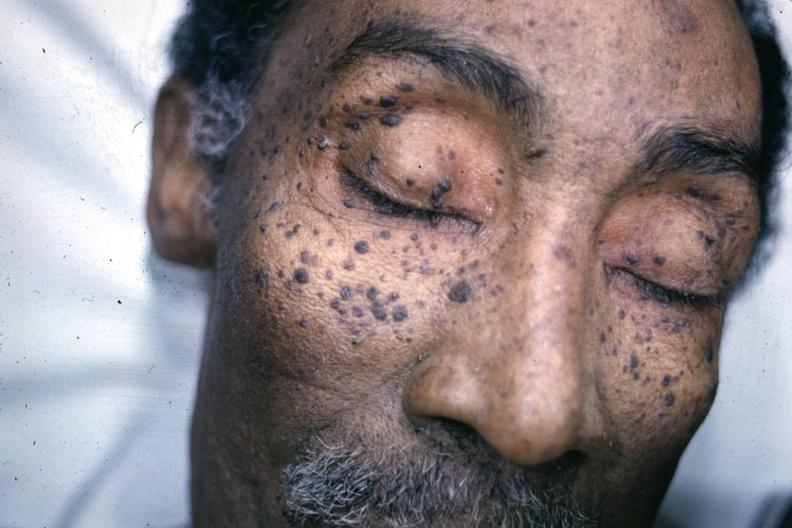does this image show photo of face with multiple typical lesions?
Answer the question using a single word or phrase. Yes 